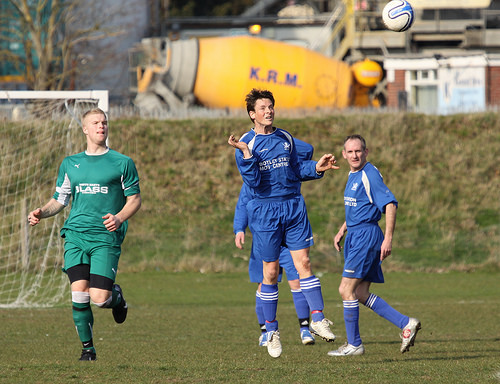<image>
Is the green player next to the blue player? Yes. The green player is positioned adjacent to the blue player, located nearby in the same general area. 